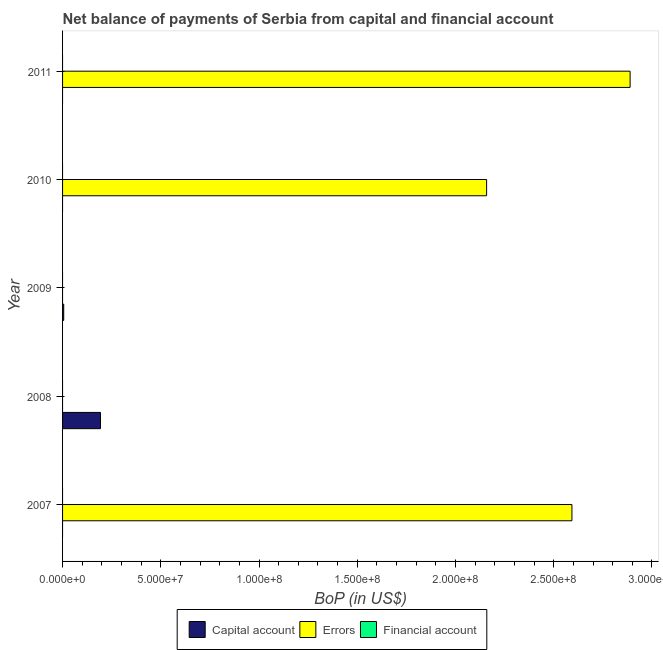How many different coloured bars are there?
Your response must be concise. 2. Are the number of bars per tick equal to the number of legend labels?
Your answer should be compact. No. How many bars are there on the 3rd tick from the bottom?
Your response must be concise. 1. What is the label of the 3rd group of bars from the top?
Offer a terse response. 2009. What is the amount of errors in 2010?
Provide a short and direct response. 2.16e+08. Across all years, what is the maximum amount of net capital account?
Provide a short and direct response. 1.93e+07. In which year was the amount of errors maximum?
Your answer should be compact. 2011. What is the difference between the amount of errors in 2010 and that in 2011?
Give a very brief answer. -7.30e+07. What is the difference between the amount of errors in 2011 and the amount of financial account in 2010?
Give a very brief answer. 2.89e+08. What is the average amount of financial account per year?
Ensure brevity in your answer.  0. In how many years, is the amount of net capital account greater than 80000000 US$?
Offer a terse response. 0. What is the ratio of the amount of errors in 2010 to that in 2011?
Offer a very short reply. 0.75. Is the amount of errors in 2010 less than that in 2011?
Offer a very short reply. Yes. What is the difference between the highest and the lowest amount of errors?
Offer a very short reply. 2.89e+08. In how many years, is the amount of financial account greater than the average amount of financial account taken over all years?
Give a very brief answer. 0. Is the sum of the amount of errors in 2010 and 2011 greater than the maximum amount of financial account across all years?
Your answer should be compact. Yes. How many bars are there?
Offer a terse response. 5. Are all the bars in the graph horizontal?
Provide a succinct answer. Yes. How many years are there in the graph?
Provide a succinct answer. 5. What is the difference between two consecutive major ticks on the X-axis?
Your answer should be compact. 5.00e+07. Are the values on the major ticks of X-axis written in scientific E-notation?
Ensure brevity in your answer.  Yes. Does the graph contain any zero values?
Keep it short and to the point. Yes. Where does the legend appear in the graph?
Provide a succinct answer. Bottom center. How are the legend labels stacked?
Provide a succinct answer. Horizontal. What is the title of the graph?
Give a very brief answer. Net balance of payments of Serbia from capital and financial account. Does "Transport services" appear as one of the legend labels in the graph?
Your answer should be very brief. No. What is the label or title of the X-axis?
Offer a terse response. BoP (in US$). What is the label or title of the Y-axis?
Your answer should be very brief. Year. What is the BoP (in US$) in Capital account in 2007?
Provide a short and direct response. 0. What is the BoP (in US$) in Errors in 2007?
Ensure brevity in your answer.  2.59e+08. What is the BoP (in US$) of Financial account in 2007?
Your response must be concise. 0. What is the BoP (in US$) in Capital account in 2008?
Offer a very short reply. 1.93e+07. What is the BoP (in US$) of Capital account in 2009?
Your answer should be very brief. 5.83e+05. What is the BoP (in US$) of Errors in 2009?
Keep it short and to the point. 0. What is the BoP (in US$) of Errors in 2010?
Keep it short and to the point. 2.16e+08. What is the BoP (in US$) in Financial account in 2010?
Provide a short and direct response. 0. What is the BoP (in US$) in Capital account in 2011?
Provide a succinct answer. 0. What is the BoP (in US$) in Errors in 2011?
Your answer should be compact. 2.89e+08. What is the BoP (in US$) of Financial account in 2011?
Your answer should be very brief. 0. Across all years, what is the maximum BoP (in US$) of Capital account?
Keep it short and to the point. 1.93e+07. Across all years, what is the maximum BoP (in US$) in Errors?
Your answer should be very brief. 2.89e+08. Across all years, what is the minimum BoP (in US$) of Capital account?
Give a very brief answer. 0. What is the total BoP (in US$) of Capital account in the graph?
Provide a succinct answer. 1.99e+07. What is the total BoP (in US$) of Errors in the graph?
Provide a succinct answer. 7.64e+08. What is the difference between the BoP (in US$) in Errors in 2007 and that in 2010?
Make the answer very short. 4.34e+07. What is the difference between the BoP (in US$) of Errors in 2007 and that in 2011?
Ensure brevity in your answer.  -2.96e+07. What is the difference between the BoP (in US$) of Capital account in 2008 and that in 2009?
Your response must be concise. 1.87e+07. What is the difference between the BoP (in US$) in Errors in 2010 and that in 2011?
Provide a succinct answer. -7.30e+07. What is the difference between the BoP (in US$) of Capital account in 2008 and the BoP (in US$) of Errors in 2010?
Provide a short and direct response. -1.97e+08. What is the difference between the BoP (in US$) in Capital account in 2008 and the BoP (in US$) in Errors in 2011?
Keep it short and to the point. -2.70e+08. What is the difference between the BoP (in US$) of Capital account in 2009 and the BoP (in US$) of Errors in 2010?
Offer a terse response. -2.15e+08. What is the difference between the BoP (in US$) of Capital account in 2009 and the BoP (in US$) of Errors in 2011?
Make the answer very short. -2.88e+08. What is the average BoP (in US$) in Capital account per year?
Your answer should be very brief. 3.98e+06. What is the average BoP (in US$) of Errors per year?
Make the answer very short. 1.53e+08. What is the average BoP (in US$) in Financial account per year?
Provide a short and direct response. 0. What is the ratio of the BoP (in US$) in Errors in 2007 to that in 2010?
Offer a terse response. 1.2. What is the ratio of the BoP (in US$) of Errors in 2007 to that in 2011?
Your answer should be very brief. 0.9. What is the ratio of the BoP (in US$) of Capital account in 2008 to that in 2009?
Your answer should be very brief. 33.09. What is the ratio of the BoP (in US$) in Errors in 2010 to that in 2011?
Provide a succinct answer. 0.75. What is the difference between the highest and the second highest BoP (in US$) in Errors?
Your response must be concise. 2.96e+07. What is the difference between the highest and the lowest BoP (in US$) in Capital account?
Make the answer very short. 1.93e+07. What is the difference between the highest and the lowest BoP (in US$) of Errors?
Your answer should be compact. 2.89e+08. 